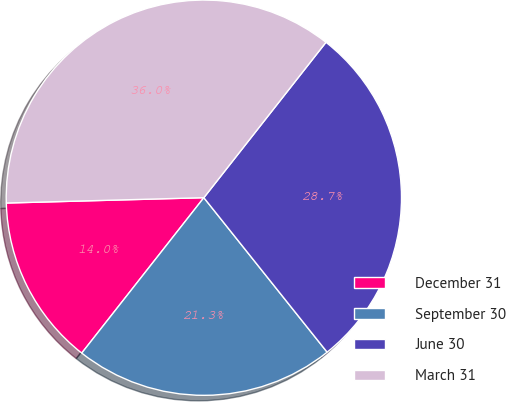Convert chart. <chart><loc_0><loc_0><loc_500><loc_500><pie_chart><fcel>December 31<fcel>September 30<fcel>June 30<fcel>March 31<nl><fcel>13.97%<fcel>21.32%<fcel>28.68%<fcel>36.03%<nl></chart> 